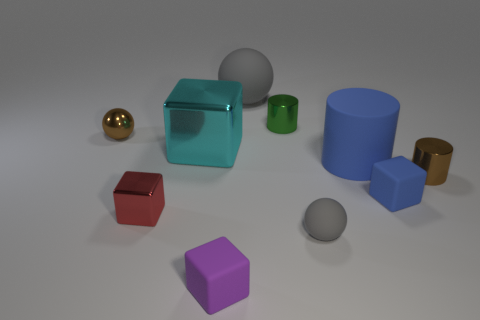What is the color of the other shiny thing that is the same shape as the red thing?
Ensure brevity in your answer.  Cyan. Does the large object to the left of the tiny purple object have the same color as the tiny ball right of the red metallic object?
Ensure brevity in your answer.  No. Is the number of gray things that are in front of the big gray thing greater than the number of big blue cylinders?
Offer a very short reply. No. How many other objects are there of the same size as the green cylinder?
Your answer should be very brief. 6. What number of things are behind the tiny brown cylinder and on the left side of the small green metal cylinder?
Provide a short and direct response. 3. Is the material of the tiny blue cube on the right side of the small purple rubber thing the same as the tiny gray sphere?
Offer a terse response. Yes. What shape is the brown thing right of the block behind the large thing that is to the right of the large gray object?
Your response must be concise. Cylinder. Are there the same number of small matte spheres right of the tiny blue object and small brown metallic balls that are behind the tiny green metallic thing?
Offer a very short reply. Yes. There is a matte sphere that is the same size as the blue rubber block; what is its color?
Make the answer very short. Gray. How many small things are green metal cylinders or yellow metallic things?
Provide a succinct answer. 1. 